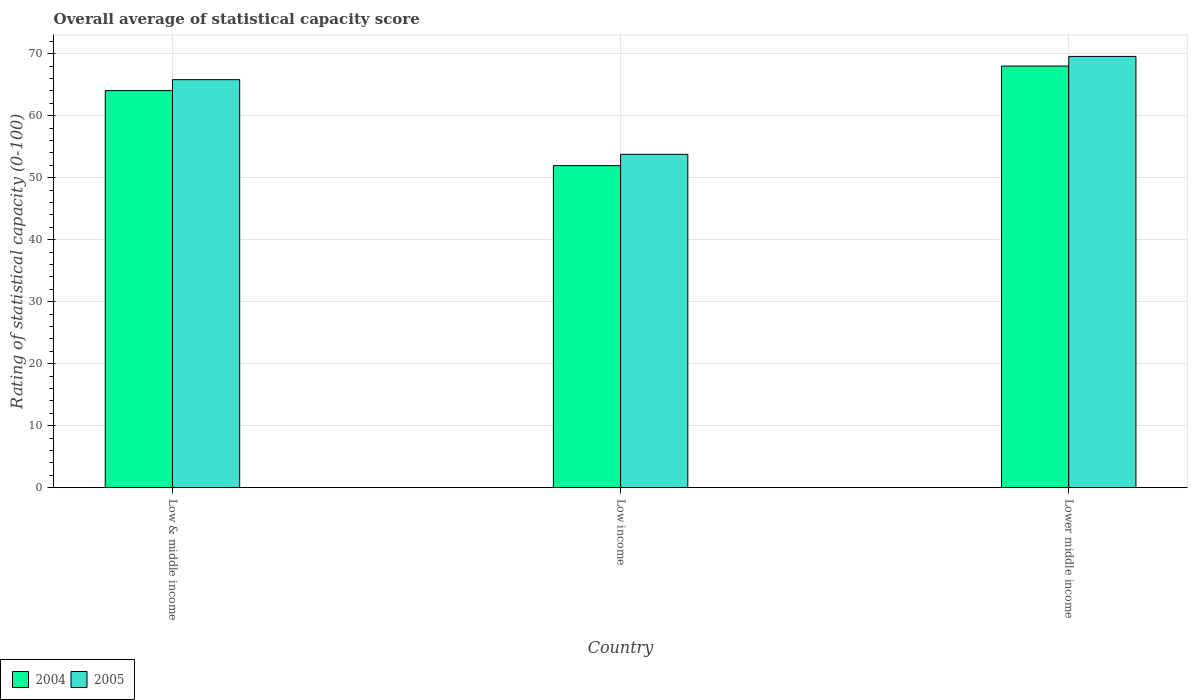How many different coloured bars are there?
Your answer should be very brief. 2. How many groups of bars are there?
Your answer should be compact. 3. How many bars are there on the 1st tick from the right?
Offer a very short reply. 2. What is the label of the 3rd group of bars from the left?
Ensure brevity in your answer.  Lower middle income. What is the rating of statistical capacity in 2005 in Low income?
Offer a terse response. 53.77. Across all countries, what is the maximum rating of statistical capacity in 2004?
Give a very brief answer. 68.01. Across all countries, what is the minimum rating of statistical capacity in 2005?
Ensure brevity in your answer.  53.77. In which country was the rating of statistical capacity in 2005 maximum?
Ensure brevity in your answer.  Lower middle income. In which country was the rating of statistical capacity in 2004 minimum?
Give a very brief answer. Low income. What is the total rating of statistical capacity in 2005 in the graph?
Your answer should be very brief. 189.14. What is the difference between the rating of statistical capacity in 2004 in Low & middle income and that in Lower middle income?
Your response must be concise. -3.96. What is the difference between the rating of statistical capacity in 2005 in Lower middle income and the rating of statistical capacity in 2004 in Low income?
Your answer should be compact. 17.62. What is the average rating of statistical capacity in 2005 per country?
Ensure brevity in your answer.  63.05. What is the difference between the rating of statistical capacity of/in 2004 and rating of statistical capacity of/in 2005 in Lower middle income?
Your response must be concise. -1.55. What is the ratio of the rating of statistical capacity in 2004 in Low & middle income to that in Lower middle income?
Give a very brief answer. 0.94. What is the difference between the highest and the second highest rating of statistical capacity in 2004?
Make the answer very short. 12.1. What is the difference between the highest and the lowest rating of statistical capacity in 2004?
Offer a terse response. 16.07. Are all the bars in the graph horizontal?
Your answer should be compact. No. What is the difference between two consecutive major ticks on the Y-axis?
Offer a very short reply. 10. Are the values on the major ticks of Y-axis written in scientific E-notation?
Offer a terse response. No. Does the graph contain grids?
Your answer should be compact. Yes. Where does the legend appear in the graph?
Your answer should be very brief. Bottom left. How many legend labels are there?
Provide a succinct answer. 2. How are the legend labels stacked?
Keep it short and to the point. Horizontal. What is the title of the graph?
Make the answer very short. Overall average of statistical capacity score. Does "1972" appear as one of the legend labels in the graph?
Make the answer very short. No. What is the label or title of the Y-axis?
Offer a terse response. Rating of statistical capacity (0-100). What is the Rating of statistical capacity (0-100) in 2004 in Low & middle income?
Provide a short and direct response. 64.05. What is the Rating of statistical capacity (0-100) of 2005 in Low & middle income?
Make the answer very short. 65.81. What is the Rating of statistical capacity (0-100) of 2004 in Low income?
Offer a very short reply. 51.94. What is the Rating of statistical capacity (0-100) of 2005 in Low income?
Your response must be concise. 53.77. What is the Rating of statistical capacity (0-100) in 2004 in Lower middle income?
Your answer should be very brief. 68.01. What is the Rating of statistical capacity (0-100) of 2005 in Lower middle income?
Your answer should be very brief. 69.56. Across all countries, what is the maximum Rating of statistical capacity (0-100) of 2004?
Your answer should be compact. 68.01. Across all countries, what is the maximum Rating of statistical capacity (0-100) of 2005?
Provide a short and direct response. 69.56. Across all countries, what is the minimum Rating of statistical capacity (0-100) of 2004?
Ensure brevity in your answer.  51.94. Across all countries, what is the minimum Rating of statistical capacity (0-100) of 2005?
Give a very brief answer. 53.77. What is the total Rating of statistical capacity (0-100) of 2004 in the graph?
Give a very brief answer. 184.01. What is the total Rating of statistical capacity (0-100) in 2005 in the graph?
Your answer should be compact. 189.14. What is the difference between the Rating of statistical capacity (0-100) of 2004 in Low & middle income and that in Low income?
Keep it short and to the point. 12.1. What is the difference between the Rating of statistical capacity (0-100) in 2005 in Low & middle income and that in Low income?
Offer a very short reply. 12.04. What is the difference between the Rating of statistical capacity (0-100) of 2004 in Low & middle income and that in Lower middle income?
Offer a very short reply. -3.96. What is the difference between the Rating of statistical capacity (0-100) in 2005 in Low & middle income and that in Lower middle income?
Keep it short and to the point. -3.75. What is the difference between the Rating of statistical capacity (0-100) in 2004 in Low income and that in Lower middle income?
Provide a short and direct response. -16.07. What is the difference between the Rating of statistical capacity (0-100) in 2005 in Low income and that in Lower middle income?
Offer a terse response. -15.79. What is the difference between the Rating of statistical capacity (0-100) in 2004 in Low & middle income and the Rating of statistical capacity (0-100) in 2005 in Low income?
Keep it short and to the point. 10.28. What is the difference between the Rating of statistical capacity (0-100) in 2004 in Low & middle income and the Rating of statistical capacity (0-100) in 2005 in Lower middle income?
Give a very brief answer. -5.51. What is the difference between the Rating of statistical capacity (0-100) in 2004 in Low income and the Rating of statistical capacity (0-100) in 2005 in Lower middle income?
Provide a short and direct response. -17.62. What is the average Rating of statistical capacity (0-100) in 2004 per country?
Your response must be concise. 61.34. What is the average Rating of statistical capacity (0-100) in 2005 per country?
Provide a succinct answer. 63.05. What is the difference between the Rating of statistical capacity (0-100) of 2004 and Rating of statistical capacity (0-100) of 2005 in Low & middle income?
Offer a terse response. -1.76. What is the difference between the Rating of statistical capacity (0-100) in 2004 and Rating of statistical capacity (0-100) in 2005 in Low income?
Your answer should be compact. -1.83. What is the difference between the Rating of statistical capacity (0-100) in 2004 and Rating of statistical capacity (0-100) in 2005 in Lower middle income?
Give a very brief answer. -1.55. What is the ratio of the Rating of statistical capacity (0-100) of 2004 in Low & middle income to that in Low income?
Provide a succinct answer. 1.23. What is the ratio of the Rating of statistical capacity (0-100) in 2005 in Low & middle income to that in Low income?
Offer a very short reply. 1.22. What is the ratio of the Rating of statistical capacity (0-100) of 2004 in Low & middle income to that in Lower middle income?
Provide a succinct answer. 0.94. What is the ratio of the Rating of statistical capacity (0-100) of 2005 in Low & middle income to that in Lower middle income?
Ensure brevity in your answer.  0.95. What is the ratio of the Rating of statistical capacity (0-100) of 2004 in Low income to that in Lower middle income?
Ensure brevity in your answer.  0.76. What is the ratio of the Rating of statistical capacity (0-100) of 2005 in Low income to that in Lower middle income?
Give a very brief answer. 0.77. What is the difference between the highest and the second highest Rating of statistical capacity (0-100) in 2004?
Keep it short and to the point. 3.96. What is the difference between the highest and the second highest Rating of statistical capacity (0-100) of 2005?
Ensure brevity in your answer.  3.75. What is the difference between the highest and the lowest Rating of statistical capacity (0-100) of 2004?
Ensure brevity in your answer.  16.07. What is the difference between the highest and the lowest Rating of statistical capacity (0-100) in 2005?
Offer a terse response. 15.79. 